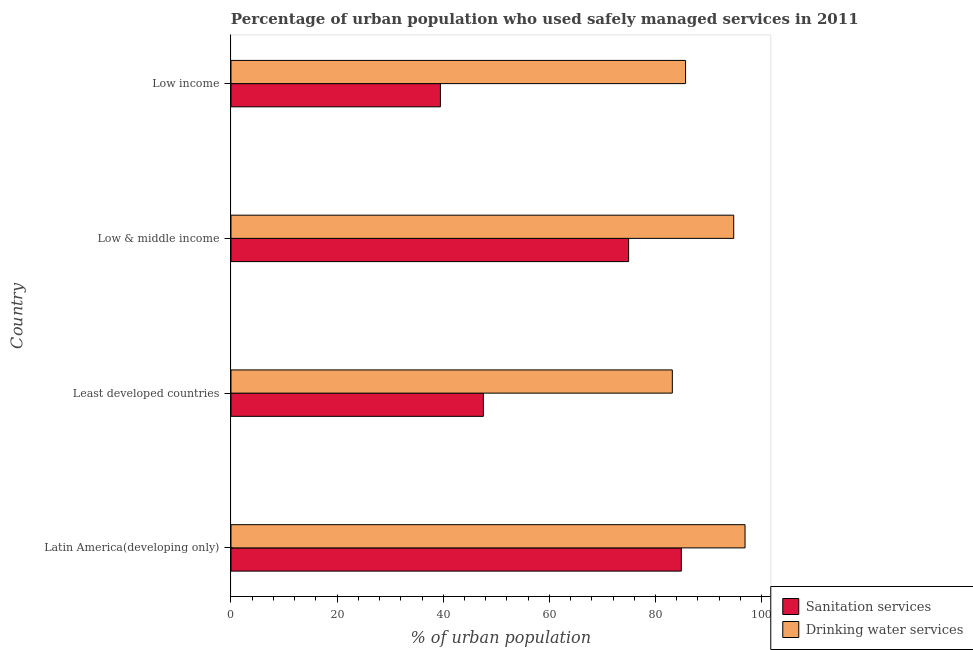How many groups of bars are there?
Provide a succinct answer. 4. Are the number of bars per tick equal to the number of legend labels?
Provide a short and direct response. Yes. How many bars are there on the 1st tick from the top?
Offer a terse response. 2. How many bars are there on the 2nd tick from the bottom?
Make the answer very short. 2. What is the label of the 4th group of bars from the top?
Keep it short and to the point. Latin America(developing only). In how many cases, is the number of bars for a given country not equal to the number of legend labels?
Provide a short and direct response. 0. What is the percentage of urban population who used sanitation services in Low & middle income?
Make the answer very short. 74.94. Across all countries, what is the maximum percentage of urban population who used sanitation services?
Ensure brevity in your answer.  84.88. Across all countries, what is the minimum percentage of urban population who used drinking water services?
Offer a terse response. 83.18. In which country was the percentage of urban population who used drinking water services maximum?
Your answer should be compact. Latin America(developing only). In which country was the percentage of urban population who used drinking water services minimum?
Ensure brevity in your answer.  Least developed countries. What is the total percentage of urban population who used sanitation services in the graph?
Keep it short and to the point. 246.85. What is the difference between the percentage of urban population who used drinking water services in Least developed countries and that in Low & middle income?
Provide a short and direct response. -11.57. What is the difference between the percentage of urban population who used sanitation services in Low & middle income and the percentage of urban population who used drinking water services in Least developed countries?
Keep it short and to the point. -8.24. What is the average percentage of urban population who used drinking water services per country?
Your answer should be very brief. 90.12. What is the difference between the percentage of urban population who used sanitation services and percentage of urban population who used drinking water services in Latin America(developing only)?
Offer a very short reply. -12.01. What is the ratio of the percentage of urban population who used sanitation services in Least developed countries to that in Low & middle income?
Your answer should be compact. 0.64. Is the difference between the percentage of urban population who used sanitation services in Least developed countries and Low income greater than the difference between the percentage of urban population who used drinking water services in Least developed countries and Low income?
Your response must be concise. Yes. What is the difference between the highest and the second highest percentage of urban population who used drinking water services?
Provide a succinct answer. 2.14. What is the difference between the highest and the lowest percentage of urban population who used sanitation services?
Provide a succinct answer. 45.41. In how many countries, is the percentage of urban population who used drinking water services greater than the average percentage of urban population who used drinking water services taken over all countries?
Provide a succinct answer. 2. Is the sum of the percentage of urban population who used sanitation services in Least developed countries and Low income greater than the maximum percentage of urban population who used drinking water services across all countries?
Offer a very short reply. No. What does the 1st bar from the top in Low & middle income represents?
Your answer should be compact. Drinking water services. What does the 2nd bar from the bottom in Low income represents?
Offer a terse response. Drinking water services. How many bars are there?
Provide a succinct answer. 8. Are all the bars in the graph horizontal?
Make the answer very short. Yes. What is the difference between two consecutive major ticks on the X-axis?
Offer a terse response. 20. What is the title of the graph?
Provide a succinct answer. Percentage of urban population who used safely managed services in 2011. Does "By country of origin" appear as one of the legend labels in the graph?
Give a very brief answer. No. What is the label or title of the X-axis?
Ensure brevity in your answer.  % of urban population. What is the label or title of the Y-axis?
Your answer should be compact. Country. What is the % of urban population of Sanitation services in Latin America(developing only)?
Keep it short and to the point. 84.88. What is the % of urban population in Drinking water services in Latin America(developing only)?
Make the answer very short. 96.88. What is the % of urban population in Sanitation services in Least developed countries?
Provide a succinct answer. 47.57. What is the % of urban population in Drinking water services in Least developed countries?
Your answer should be compact. 83.18. What is the % of urban population in Sanitation services in Low & middle income?
Your answer should be very brief. 74.94. What is the % of urban population in Drinking water services in Low & middle income?
Keep it short and to the point. 94.75. What is the % of urban population in Sanitation services in Low income?
Give a very brief answer. 39.47. What is the % of urban population of Drinking water services in Low income?
Offer a very short reply. 85.67. Across all countries, what is the maximum % of urban population of Sanitation services?
Your answer should be compact. 84.88. Across all countries, what is the maximum % of urban population of Drinking water services?
Ensure brevity in your answer.  96.88. Across all countries, what is the minimum % of urban population in Sanitation services?
Keep it short and to the point. 39.47. Across all countries, what is the minimum % of urban population in Drinking water services?
Your answer should be compact. 83.18. What is the total % of urban population of Sanitation services in the graph?
Give a very brief answer. 246.85. What is the total % of urban population in Drinking water services in the graph?
Ensure brevity in your answer.  360.48. What is the difference between the % of urban population of Sanitation services in Latin America(developing only) and that in Least developed countries?
Provide a short and direct response. 37.31. What is the difference between the % of urban population of Drinking water services in Latin America(developing only) and that in Least developed countries?
Ensure brevity in your answer.  13.7. What is the difference between the % of urban population in Sanitation services in Latin America(developing only) and that in Low & middle income?
Your response must be concise. 9.93. What is the difference between the % of urban population in Drinking water services in Latin America(developing only) and that in Low & middle income?
Your response must be concise. 2.14. What is the difference between the % of urban population in Sanitation services in Latin America(developing only) and that in Low income?
Keep it short and to the point. 45.41. What is the difference between the % of urban population in Drinking water services in Latin America(developing only) and that in Low income?
Your answer should be compact. 11.21. What is the difference between the % of urban population of Sanitation services in Least developed countries and that in Low & middle income?
Offer a terse response. -27.37. What is the difference between the % of urban population of Drinking water services in Least developed countries and that in Low & middle income?
Your answer should be compact. -11.57. What is the difference between the % of urban population in Sanitation services in Least developed countries and that in Low income?
Your response must be concise. 8.1. What is the difference between the % of urban population in Drinking water services in Least developed countries and that in Low income?
Offer a terse response. -2.49. What is the difference between the % of urban population of Sanitation services in Low & middle income and that in Low income?
Keep it short and to the point. 35.47. What is the difference between the % of urban population of Drinking water services in Low & middle income and that in Low income?
Keep it short and to the point. 9.07. What is the difference between the % of urban population in Sanitation services in Latin America(developing only) and the % of urban population in Drinking water services in Least developed countries?
Keep it short and to the point. 1.7. What is the difference between the % of urban population in Sanitation services in Latin America(developing only) and the % of urban population in Drinking water services in Low & middle income?
Offer a terse response. -9.87. What is the difference between the % of urban population of Sanitation services in Latin America(developing only) and the % of urban population of Drinking water services in Low income?
Provide a succinct answer. -0.8. What is the difference between the % of urban population in Sanitation services in Least developed countries and the % of urban population in Drinking water services in Low & middle income?
Your answer should be very brief. -47.18. What is the difference between the % of urban population in Sanitation services in Least developed countries and the % of urban population in Drinking water services in Low income?
Your response must be concise. -38.1. What is the difference between the % of urban population in Sanitation services in Low & middle income and the % of urban population in Drinking water services in Low income?
Make the answer very short. -10.73. What is the average % of urban population of Sanitation services per country?
Make the answer very short. 61.71. What is the average % of urban population in Drinking water services per country?
Offer a terse response. 90.12. What is the difference between the % of urban population of Sanitation services and % of urban population of Drinking water services in Latin America(developing only)?
Give a very brief answer. -12.01. What is the difference between the % of urban population of Sanitation services and % of urban population of Drinking water services in Least developed countries?
Give a very brief answer. -35.61. What is the difference between the % of urban population of Sanitation services and % of urban population of Drinking water services in Low & middle income?
Make the answer very short. -19.8. What is the difference between the % of urban population in Sanitation services and % of urban population in Drinking water services in Low income?
Offer a terse response. -46.2. What is the ratio of the % of urban population in Sanitation services in Latin America(developing only) to that in Least developed countries?
Provide a succinct answer. 1.78. What is the ratio of the % of urban population in Drinking water services in Latin America(developing only) to that in Least developed countries?
Provide a succinct answer. 1.16. What is the ratio of the % of urban population of Sanitation services in Latin America(developing only) to that in Low & middle income?
Make the answer very short. 1.13. What is the ratio of the % of urban population in Drinking water services in Latin America(developing only) to that in Low & middle income?
Provide a succinct answer. 1.02. What is the ratio of the % of urban population in Sanitation services in Latin America(developing only) to that in Low income?
Your answer should be compact. 2.15. What is the ratio of the % of urban population of Drinking water services in Latin America(developing only) to that in Low income?
Make the answer very short. 1.13. What is the ratio of the % of urban population in Sanitation services in Least developed countries to that in Low & middle income?
Offer a terse response. 0.63. What is the ratio of the % of urban population in Drinking water services in Least developed countries to that in Low & middle income?
Your answer should be very brief. 0.88. What is the ratio of the % of urban population of Sanitation services in Least developed countries to that in Low income?
Your answer should be compact. 1.21. What is the ratio of the % of urban population of Drinking water services in Least developed countries to that in Low income?
Give a very brief answer. 0.97. What is the ratio of the % of urban population of Sanitation services in Low & middle income to that in Low income?
Ensure brevity in your answer.  1.9. What is the ratio of the % of urban population of Drinking water services in Low & middle income to that in Low income?
Offer a terse response. 1.11. What is the difference between the highest and the second highest % of urban population of Sanitation services?
Your answer should be very brief. 9.93. What is the difference between the highest and the second highest % of urban population in Drinking water services?
Ensure brevity in your answer.  2.14. What is the difference between the highest and the lowest % of urban population of Sanitation services?
Offer a terse response. 45.41. What is the difference between the highest and the lowest % of urban population of Drinking water services?
Offer a terse response. 13.7. 